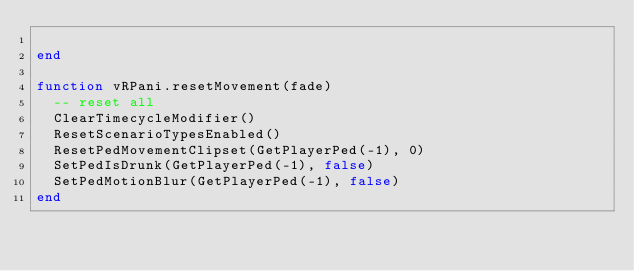<code> <loc_0><loc_0><loc_500><loc_500><_Lua_>  
end

function vRPani.resetMovement(fade)
  -- reset all
  ClearTimecycleModifier()
  ResetScenarioTypesEnabled()
  ResetPedMovementClipset(GetPlayerPed(-1), 0)
  SetPedIsDrunk(GetPlayerPed(-1), false)
  SetPedMotionBlur(GetPlayerPed(-1), false)
end</code> 